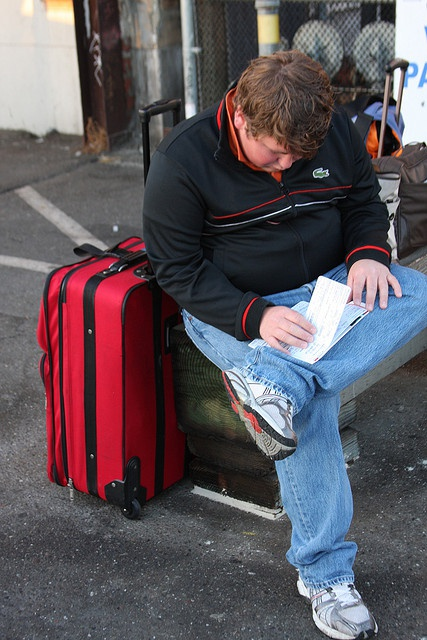Describe the objects in this image and their specific colors. I can see people in lightgray, black, darkgray, lavender, and gray tones, suitcase in lightgray, black, brown, and maroon tones, bench in lightgray, black, gray, darkgray, and darkgreen tones, and bench in lightgray, gray, black, and purple tones in this image. 